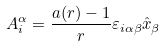Convert formula to latex. <formula><loc_0><loc_0><loc_500><loc_500>A ^ { \alpha } _ { i } = \frac { a ( r ) - 1 } { r } \varepsilon _ { i \alpha \beta } \hat { x } _ { \beta }</formula> 